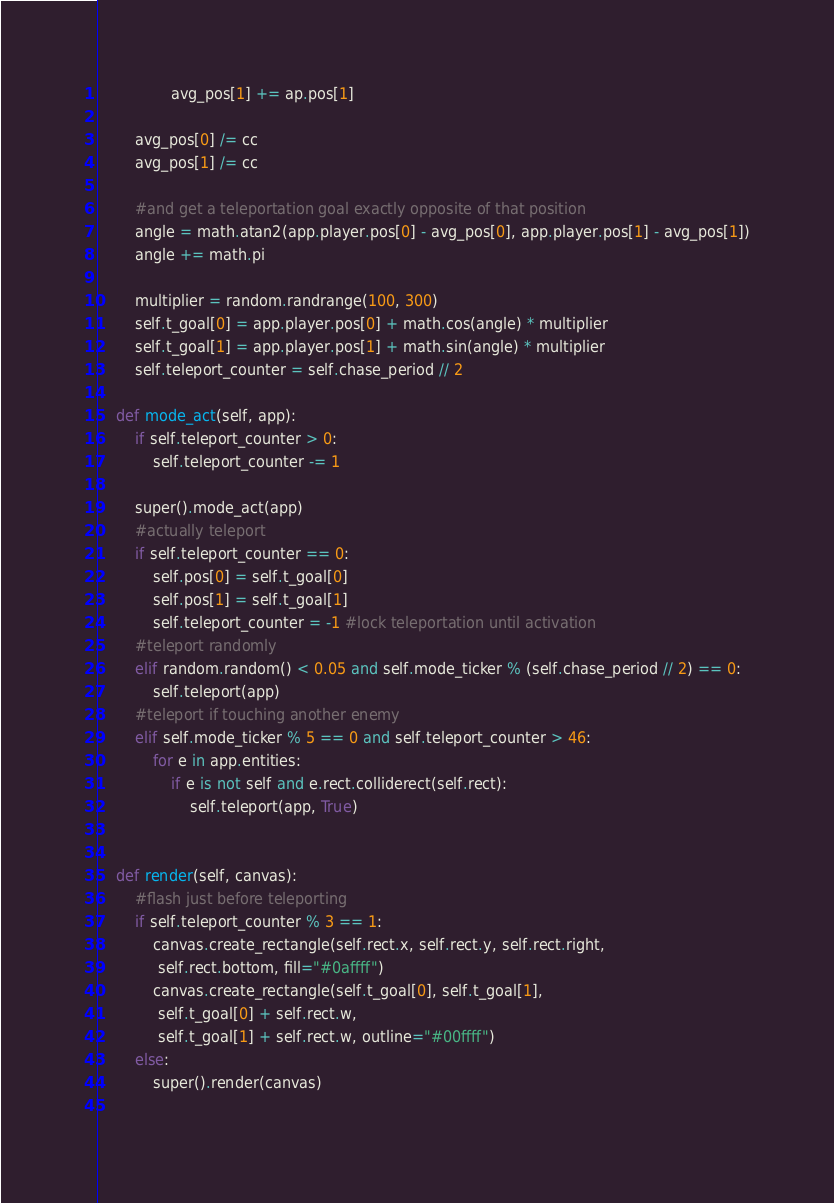<code> <loc_0><loc_0><loc_500><loc_500><_Python_>                avg_pos[1] += ap.pos[1]

        avg_pos[0] /= cc
        avg_pos[1] /= cc
        
        #and get a teleportation goal exactly opposite of that position
        angle = math.atan2(app.player.pos[0] - avg_pos[0], app.player.pos[1] - avg_pos[1])
        angle += math.pi

        multiplier = random.randrange(100, 300)
        self.t_goal[0] = app.player.pos[0] + math.cos(angle) * multiplier
        self.t_goal[1] = app.player.pos[1] + math.sin(angle) * multiplier
        self.teleport_counter = self.chase_period // 2

    def mode_act(self, app):
        if self.teleport_counter > 0:
            self.teleport_counter -= 1

        super().mode_act(app)
        #actually teleport
        if self.teleport_counter == 0:
            self.pos[0] = self.t_goal[0]
            self.pos[1] = self.t_goal[1]
            self.teleport_counter = -1 #lock teleportation until activation
        #teleport randomly
        elif random.random() < 0.05 and self.mode_ticker % (self.chase_period // 2) == 0:
            self.teleport(app)
        #teleport if touching another enemy
        elif self.mode_ticker % 5 == 0 and self.teleport_counter > 46: 
            for e in app.entities:
                if e is not self and e.rect.colliderect(self.rect):
                    self.teleport(app, True)


    def render(self, canvas):
        #flash just before teleporting
        if self.teleport_counter % 3 == 1:
            canvas.create_rectangle(self.rect.x, self.rect.y, self.rect.right,
             self.rect.bottom, fill="#0affff")
            canvas.create_rectangle(self.t_goal[0], self.t_goal[1],
             self.t_goal[0] + self.rect.w,
             self.t_goal[1] + self.rect.w, outline="#00ffff")
        else:
            super().render(canvas)
  </code> 